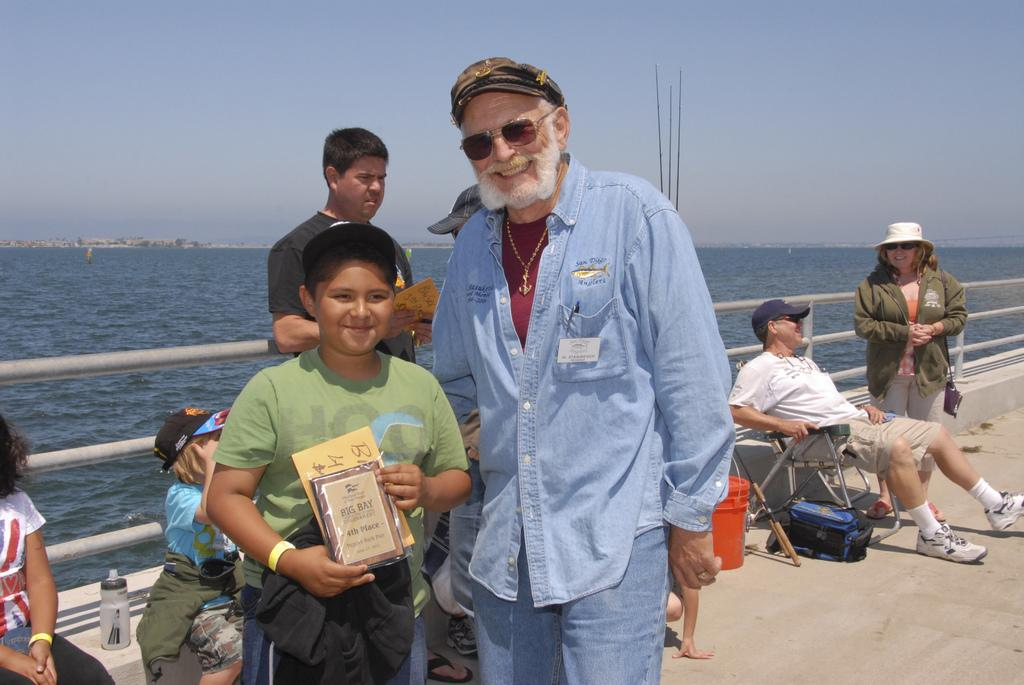What is located in the middle of the image? There is water in the middle of the image. What are the people in the image doing? Some of the persons are sitting, and some are standing. What is visible at the top of the image? The sky is visible at the top of the image. How much debt is being discussed by the persons in the image? There is no indication in the image that the persons are discussing debt, so it cannot be determined from the picture. 